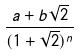<formula> <loc_0><loc_0><loc_500><loc_500>\frac { a + b \sqrt { 2 } } { ( 1 + \sqrt { 2 } ) ^ { n } }</formula> 